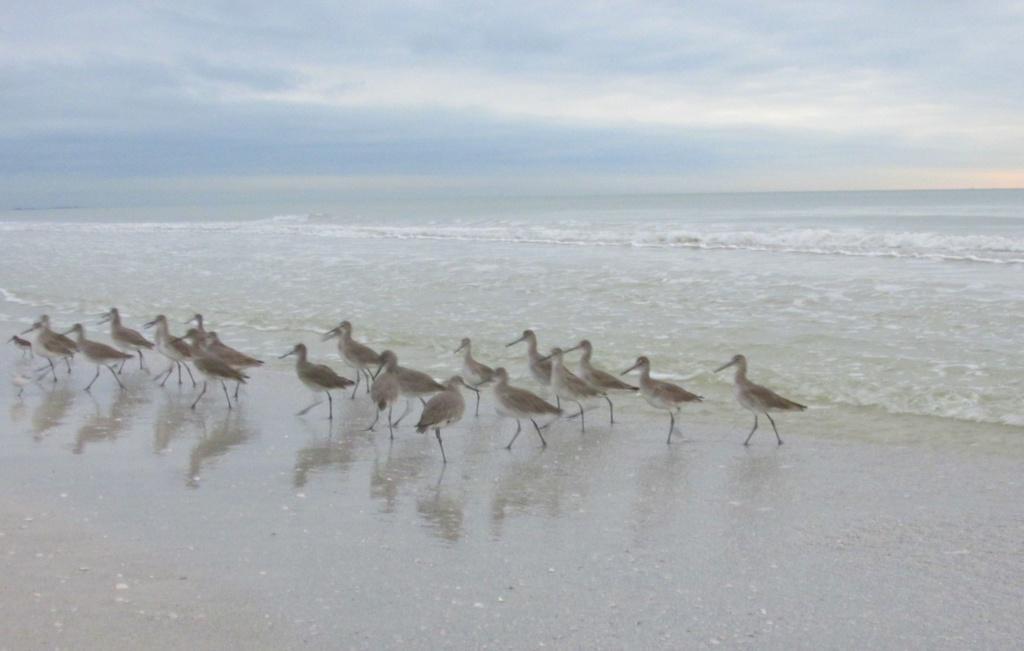In one or two sentences, can you explain what this image depicts? In the center of the image we can see the birds. In the background of the image we can see the ocean. At the bottom of the image we can see the soil. At the top of the image we can see the clouds are present in the sky. 